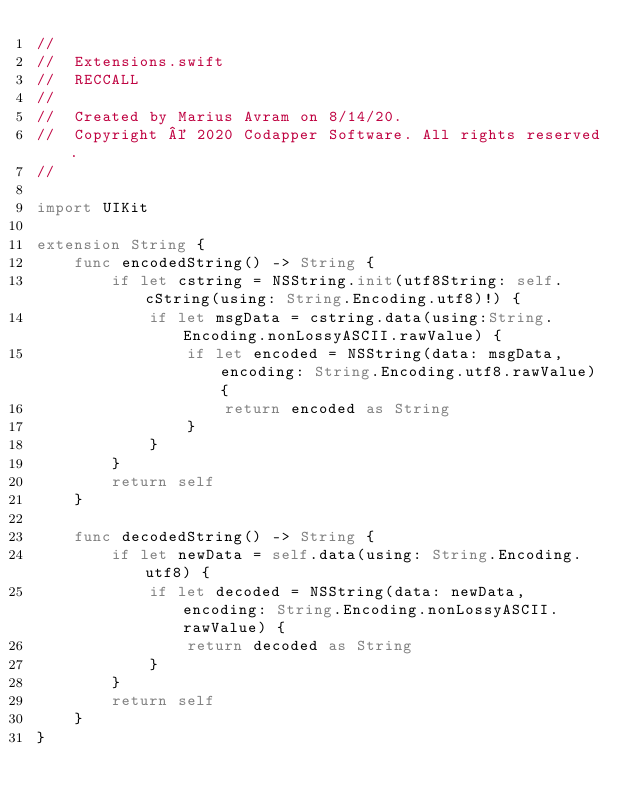<code> <loc_0><loc_0><loc_500><loc_500><_Swift_>//
//  Extensions.swift
//  RECCALL
//
//  Created by Marius Avram on 8/14/20.
//  Copyright © 2020 Codapper Software. All rights reserved.
//

import UIKit

extension String {
    func encodedString() -> String {
        if let cstring = NSString.init(utf8String: self.cString(using: String.Encoding.utf8)!) {
            if let msgData = cstring.data(using:String.Encoding.nonLossyASCII.rawValue) {
                if let encoded = NSString(data: msgData, encoding: String.Encoding.utf8.rawValue) {
                    return encoded as String
                }
            }
        }
        return self
    }
    
    func decodedString() -> String {
        if let newData = self.data(using: String.Encoding.utf8) {
            if let decoded = NSString(data: newData, encoding: String.Encoding.nonLossyASCII.rawValue) {
                return decoded as String
            }
        }
        return self
    }
}
</code> 